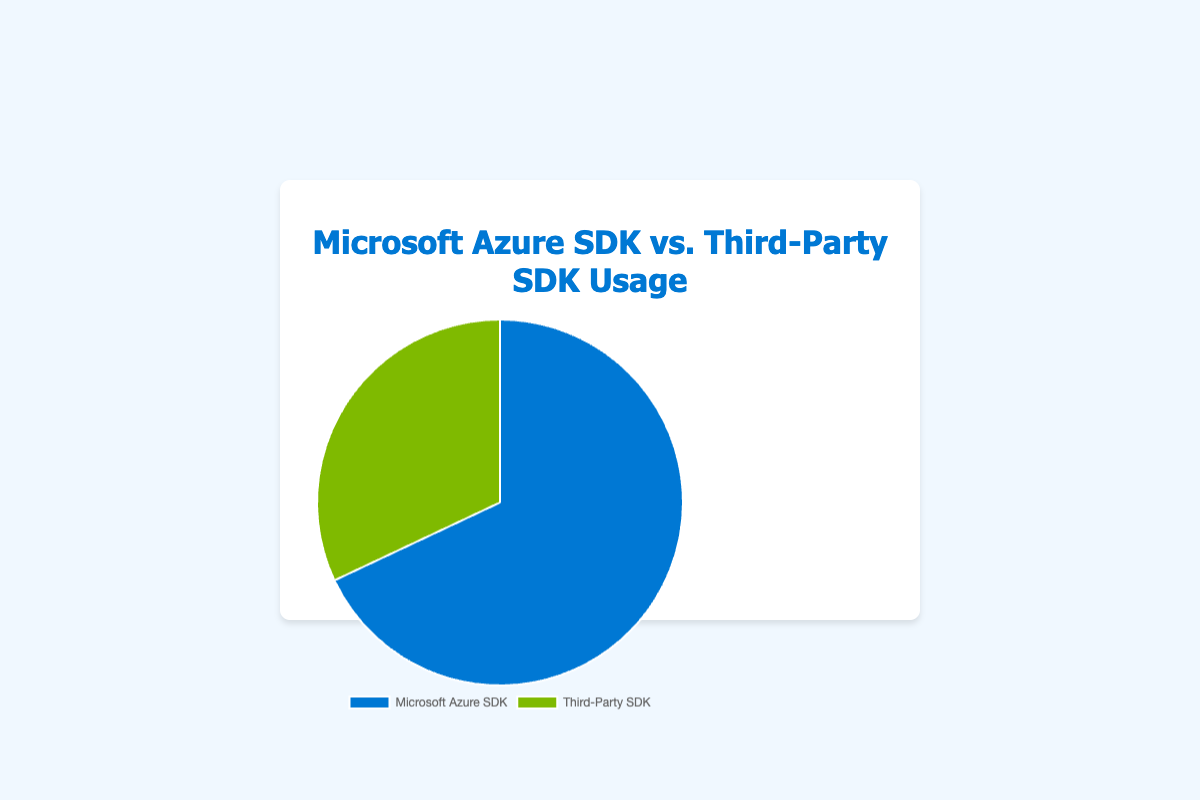What percentage of usage does Microsoft Azure SDK have? The Microsoft Azure SDK accounts for 68% of the total usage as illustrated in the pie chart's data points.
Answer: 68% Which SDK category has a higher usage percentage? By comparing the data points, the Microsoft Azure SDK has a higher usage percentage (68%) compared to the Third-Party SDK (32%).
Answer: Microsoft Azure SDK How much more is the usage percentage of Microsoft Azure SDK compared to Third-Party SDK? Subtract the percentage of the Third-Party SDK (32%) from the Microsoft Azure SDK (68%) to find the difference. 68% - 32% = 36%.
Answer: 36% What fraction of the total SDK usage is represented by Third-Party SDK? The Third-Party SDK represents 32% of the total, which can be expressed as a fraction. 32% = 32/100 = 8/25.
Answer: 8/25 If the total number of SDK users is 1000, how many users utilize the Microsoft Azure SDK? Multiply the total number of users by the percentage using the Microsoft Azure SDK: 1000 users * 68% = 680 users.
Answer: 680 What proportion of SDK usage is not covered by Microsoft Azure SDK? Subtract the percentage of Microsoft Azure SDK from 100% to find the proportion not covered. 100% - 68% = 32%.
Answer: 32% Is the difference between the usage of Microsoft Azure SDK and Third-Party SDK more than 30%? Compute the difference between the two percentages: 68% - 32% = 36%. Since 36% is more than 30%, the answer is yes.
Answer: Yes What's the ratio of Microsoft Azure SDK usage to Third-Party SDK usage? Divide the percentage of Microsoft Azure SDK by the percentage of Third-Party SDK: 68 / 32 = 2.125, or approximately 2.1 when rounded to one decimal place.
Answer: 2.1 If the Third-Party SDK usage increases by 10%, would its usage surpass the Microsoft Azure SDK? If the Third-Party SDK increases by 10%, its usage would be 32% + 10% = 42%. Compare this with Microsoft Azure SDK's 68%: 42% is still less than 68%, so it would not surpass it.
Answer: No What colors represent the Microsoft Azure SDK and Third-Party SDK in the pie chart? The Microsoft Azure SDK is represented by blue, and the Third-Party SDK is represented by green in the pie chart.
Answer: Blue for Microsoft Azure SDK, Green for Third-Party SDK 